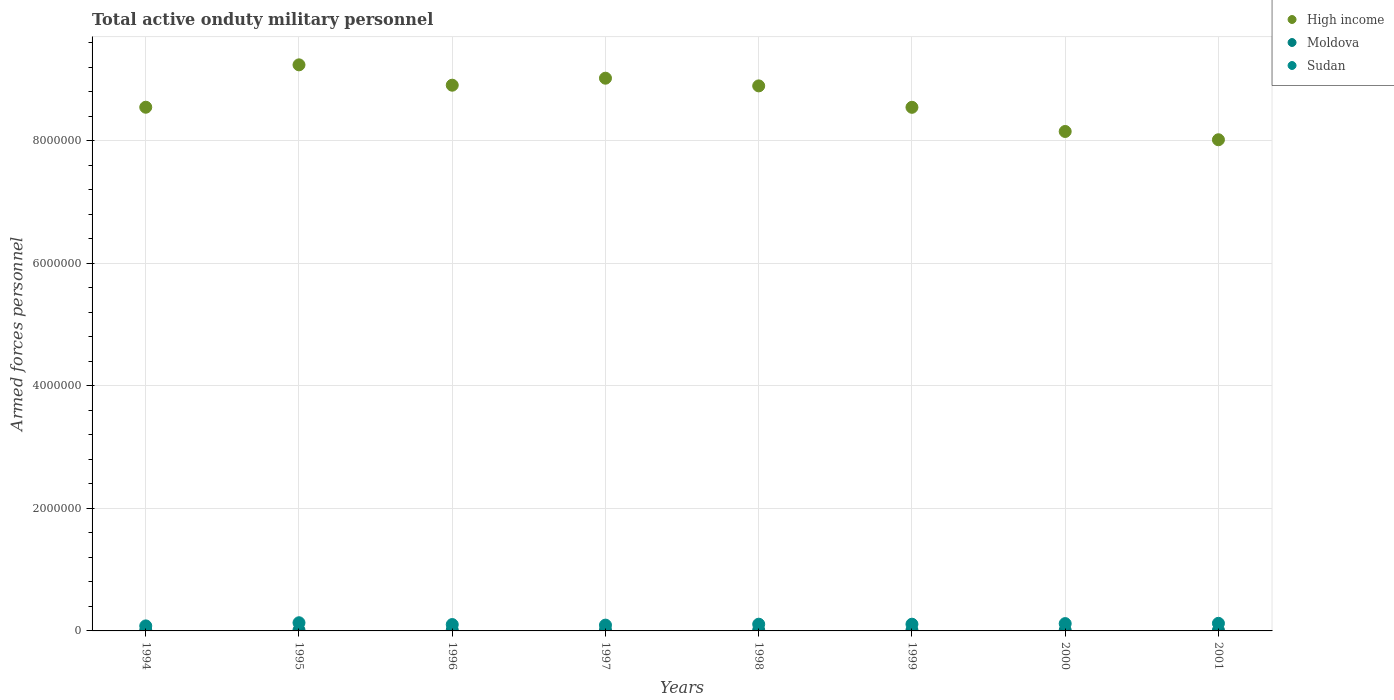How many different coloured dotlines are there?
Provide a succinct answer. 3. Is the number of dotlines equal to the number of legend labels?
Provide a succinct answer. Yes. What is the number of armed forces personnel in Sudan in 1999?
Offer a very short reply. 1.10e+05. Across all years, what is the maximum number of armed forces personnel in Sudan?
Make the answer very short. 1.34e+05. Across all years, what is the minimum number of armed forces personnel in Moldova?
Provide a succinct answer. 1.10e+04. In which year was the number of armed forces personnel in Sudan minimum?
Make the answer very short. 1994. What is the total number of armed forces personnel in High income in the graph?
Keep it short and to the point. 6.94e+07. What is the difference between the number of armed forces personnel in High income in 1998 and that in 2001?
Give a very brief answer. 8.79e+05. What is the difference between the number of armed forces personnel in Sudan in 2000 and the number of armed forces personnel in Moldova in 2001?
Your answer should be very brief. 1.08e+05. What is the average number of armed forces personnel in Moldova per year?
Your response must be concise. 1.36e+04. In the year 1994, what is the difference between the number of armed forces personnel in Moldova and number of armed forces personnel in High income?
Your response must be concise. -8.54e+06. What is the ratio of the number of armed forces personnel in Moldova in 1995 to that in 1996?
Provide a short and direct response. 1. Is the number of armed forces personnel in High income in 1997 less than that in 2001?
Give a very brief answer. No. What is the difference between the highest and the second highest number of armed forces personnel in High income?
Provide a succinct answer. 2.18e+05. What is the difference between the highest and the lowest number of armed forces personnel in Moldova?
Make the answer very short. 4300. In how many years, is the number of armed forces personnel in High income greater than the average number of armed forces personnel in High income taken over all years?
Give a very brief answer. 4. Is the sum of the number of armed forces personnel in High income in 1998 and 1999 greater than the maximum number of armed forces personnel in Sudan across all years?
Ensure brevity in your answer.  Yes. Does the number of armed forces personnel in Sudan monotonically increase over the years?
Give a very brief answer. No. Is the number of armed forces personnel in High income strictly greater than the number of armed forces personnel in Sudan over the years?
Your answer should be very brief. Yes. Does the graph contain any zero values?
Give a very brief answer. No. Does the graph contain grids?
Provide a short and direct response. Yes. What is the title of the graph?
Give a very brief answer. Total active onduty military personnel. What is the label or title of the Y-axis?
Provide a succinct answer. Armed forces personnel. What is the Armed forces personnel of High income in 1994?
Ensure brevity in your answer.  8.55e+06. What is the Armed forces personnel in Moldova in 1994?
Make the answer very short. 1.10e+04. What is the Armed forces personnel of Sudan in 1994?
Provide a short and direct response. 8.20e+04. What is the Armed forces personnel of High income in 1995?
Ensure brevity in your answer.  9.24e+06. What is the Armed forces personnel in Moldova in 1995?
Keep it short and to the point. 1.53e+04. What is the Armed forces personnel of Sudan in 1995?
Offer a terse response. 1.34e+05. What is the Armed forces personnel of High income in 1996?
Offer a very short reply. 8.91e+06. What is the Armed forces personnel of Moldova in 1996?
Your response must be concise. 1.53e+04. What is the Armed forces personnel of Sudan in 1996?
Your answer should be compact. 1.04e+05. What is the Armed forces personnel of High income in 1997?
Offer a very short reply. 9.03e+06. What is the Armed forces personnel of Moldova in 1997?
Ensure brevity in your answer.  1.44e+04. What is the Armed forces personnel of Sudan in 1997?
Your response must be concise. 9.47e+04. What is the Armed forces personnel in High income in 1998?
Provide a succinct answer. 8.90e+06. What is the Armed forces personnel of Moldova in 1998?
Offer a terse response. 1.44e+04. What is the Armed forces personnel of Sudan in 1998?
Your answer should be compact. 1.10e+05. What is the Armed forces personnel of High income in 1999?
Provide a succinct answer. 8.55e+06. What is the Armed forces personnel in Moldova in 1999?
Provide a short and direct response. 1.40e+04. What is the Armed forces personnel in Sudan in 1999?
Make the answer very short. 1.10e+05. What is the Armed forces personnel of High income in 2000?
Your response must be concise. 8.16e+06. What is the Armed forces personnel of Moldova in 2000?
Your response must be concise. 1.29e+04. What is the Armed forces personnel in Sudan in 2000?
Give a very brief answer. 1.20e+05. What is the Armed forces personnel in High income in 2001?
Offer a terse response. 8.02e+06. What is the Armed forces personnel in Moldova in 2001?
Offer a terse response. 1.16e+04. What is the Armed forces personnel of Sudan in 2001?
Make the answer very short. 1.24e+05. Across all years, what is the maximum Armed forces personnel in High income?
Give a very brief answer. 9.24e+06. Across all years, what is the maximum Armed forces personnel of Moldova?
Ensure brevity in your answer.  1.53e+04. Across all years, what is the maximum Armed forces personnel of Sudan?
Your answer should be compact. 1.34e+05. Across all years, what is the minimum Armed forces personnel in High income?
Offer a terse response. 8.02e+06. Across all years, what is the minimum Armed forces personnel in Moldova?
Keep it short and to the point. 1.10e+04. Across all years, what is the minimum Armed forces personnel of Sudan?
Provide a succinct answer. 8.20e+04. What is the total Armed forces personnel of High income in the graph?
Your response must be concise. 6.94e+07. What is the total Armed forces personnel in Moldova in the graph?
Your answer should be very brief. 1.09e+05. What is the total Armed forces personnel in Sudan in the graph?
Offer a very short reply. 8.77e+05. What is the difference between the Armed forces personnel of High income in 1994 and that in 1995?
Provide a succinct answer. -6.92e+05. What is the difference between the Armed forces personnel in Moldova in 1994 and that in 1995?
Provide a succinct answer. -4300. What is the difference between the Armed forces personnel in Sudan in 1994 and that in 1995?
Provide a short and direct response. -5.15e+04. What is the difference between the Armed forces personnel in High income in 1994 and that in 1996?
Make the answer very short. -3.60e+05. What is the difference between the Armed forces personnel in Moldova in 1994 and that in 1996?
Provide a short and direct response. -4300. What is the difference between the Armed forces personnel of Sudan in 1994 and that in 1996?
Ensure brevity in your answer.  -2.20e+04. What is the difference between the Armed forces personnel in High income in 1994 and that in 1997?
Provide a short and direct response. -4.74e+05. What is the difference between the Armed forces personnel in Moldova in 1994 and that in 1997?
Your answer should be very brief. -3430. What is the difference between the Armed forces personnel in Sudan in 1994 and that in 1997?
Make the answer very short. -1.27e+04. What is the difference between the Armed forces personnel in High income in 1994 and that in 1998?
Provide a succinct answer. -3.48e+05. What is the difference between the Armed forces personnel of Moldova in 1994 and that in 1998?
Offer a very short reply. -3450. What is the difference between the Armed forces personnel in Sudan in 1994 and that in 1998?
Your answer should be very brief. -2.77e+04. What is the difference between the Armed forces personnel in High income in 1994 and that in 1999?
Give a very brief answer. 1230. What is the difference between the Armed forces personnel of Moldova in 1994 and that in 1999?
Make the answer very short. -3050. What is the difference between the Armed forces personnel of Sudan in 1994 and that in 1999?
Give a very brief answer. -2.77e+04. What is the difference between the Armed forces personnel of High income in 1994 and that in 2000?
Make the answer very short. 3.96e+05. What is the difference between the Armed forces personnel in Moldova in 1994 and that in 2000?
Provide a short and direct response. -1900. What is the difference between the Armed forces personnel of Sudan in 1994 and that in 2000?
Provide a succinct answer. -3.75e+04. What is the difference between the Armed forces personnel of High income in 1994 and that in 2001?
Offer a very short reply. 5.31e+05. What is the difference between the Armed forces personnel of Moldova in 1994 and that in 2001?
Give a very brief answer. -600. What is the difference between the Armed forces personnel of Sudan in 1994 and that in 2001?
Give a very brief answer. -4.20e+04. What is the difference between the Armed forces personnel in High income in 1995 and that in 1996?
Make the answer very short. 3.32e+05. What is the difference between the Armed forces personnel of Sudan in 1995 and that in 1996?
Offer a very short reply. 2.95e+04. What is the difference between the Armed forces personnel in High income in 1995 and that in 1997?
Give a very brief answer. 2.18e+05. What is the difference between the Armed forces personnel of Moldova in 1995 and that in 1997?
Your answer should be compact. 870. What is the difference between the Armed forces personnel in Sudan in 1995 and that in 1997?
Keep it short and to the point. 3.88e+04. What is the difference between the Armed forces personnel in High income in 1995 and that in 1998?
Offer a terse response. 3.44e+05. What is the difference between the Armed forces personnel of Moldova in 1995 and that in 1998?
Offer a very short reply. 850. What is the difference between the Armed forces personnel of Sudan in 1995 and that in 1998?
Provide a succinct answer. 2.38e+04. What is the difference between the Armed forces personnel of High income in 1995 and that in 1999?
Offer a terse response. 6.93e+05. What is the difference between the Armed forces personnel of Moldova in 1995 and that in 1999?
Make the answer very short. 1250. What is the difference between the Armed forces personnel of Sudan in 1995 and that in 1999?
Keep it short and to the point. 2.38e+04. What is the difference between the Armed forces personnel of High income in 1995 and that in 2000?
Ensure brevity in your answer.  1.09e+06. What is the difference between the Armed forces personnel of Moldova in 1995 and that in 2000?
Offer a terse response. 2400. What is the difference between the Armed forces personnel in Sudan in 1995 and that in 2000?
Offer a terse response. 1.40e+04. What is the difference between the Armed forces personnel in High income in 1995 and that in 2001?
Give a very brief answer. 1.22e+06. What is the difference between the Armed forces personnel of Moldova in 1995 and that in 2001?
Your answer should be compact. 3700. What is the difference between the Armed forces personnel of Sudan in 1995 and that in 2001?
Ensure brevity in your answer.  9500. What is the difference between the Armed forces personnel of High income in 1996 and that in 1997?
Provide a succinct answer. -1.14e+05. What is the difference between the Armed forces personnel of Moldova in 1996 and that in 1997?
Give a very brief answer. 870. What is the difference between the Armed forces personnel of Sudan in 1996 and that in 1997?
Provide a succinct answer. 9300. What is the difference between the Armed forces personnel of High income in 1996 and that in 1998?
Your answer should be compact. 1.13e+04. What is the difference between the Armed forces personnel of Moldova in 1996 and that in 1998?
Ensure brevity in your answer.  850. What is the difference between the Armed forces personnel of Sudan in 1996 and that in 1998?
Keep it short and to the point. -5700. What is the difference between the Armed forces personnel in High income in 1996 and that in 1999?
Offer a very short reply. 3.61e+05. What is the difference between the Armed forces personnel of Moldova in 1996 and that in 1999?
Your answer should be very brief. 1250. What is the difference between the Armed forces personnel in Sudan in 1996 and that in 1999?
Give a very brief answer. -5700. What is the difference between the Armed forces personnel of High income in 1996 and that in 2000?
Your answer should be very brief. 7.56e+05. What is the difference between the Armed forces personnel in Moldova in 1996 and that in 2000?
Offer a very short reply. 2400. What is the difference between the Armed forces personnel in Sudan in 1996 and that in 2000?
Your answer should be very brief. -1.55e+04. What is the difference between the Armed forces personnel of High income in 1996 and that in 2001?
Your response must be concise. 8.91e+05. What is the difference between the Armed forces personnel in Moldova in 1996 and that in 2001?
Ensure brevity in your answer.  3700. What is the difference between the Armed forces personnel of High income in 1997 and that in 1998?
Ensure brevity in your answer.  1.26e+05. What is the difference between the Armed forces personnel in Sudan in 1997 and that in 1998?
Offer a very short reply. -1.50e+04. What is the difference between the Armed forces personnel in High income in 1997 and that in 1999?
Give a very brief answer. 4.75e+05. What is the difference between the Armed forces personnel in Moldova in 1997 and that in 1999?
Ensure brevity in your answer.  380. What is the difference between the Armed forces personnel in Sudan in 1997 and that in 1999?
Keep it short and to the point. -1.50e+04. What is the difference between the Armed forces personnel of High income in 1997 and that in 2000?
Ensure brevity in your answer.  8.70e+05. What is the difference between the Armed forces personnel in Moldova in 1997 and that in 2000?
Give a very brief answer. 1530. What is the difference between the Armed forces personnel in Sudan in 1997 and that in 2000?
Your answer should be compact. -2.48e+04. What is the difference between the Armed forces personnel of High income in 1997 and that in 2001?
Your response must be concise. 1.01e+06. What is the difference between the Armed forces personnel of Moldova in 1997 and that in 2001?
Ensure brevity in your answer.  2830. What is the difference between the Armed forces personnel of Sudan in 1997 and that in 2001?
Keep it short and to the point. -2.93e+04. What is the difference between the Armed forces personnel of High income in 1998 and that in 1999?
Offer a terse response. 3.50e+05. What is the difference between the Armed forces personnel in Moldova in 1998 and that in 1999?
Offer a terse response. 400. What is the difference between the Armed forces personnel of High income in 1998 and that in 2000?
Give a very brief answer. 7.44e+05. What is the difference between the Armed forces personnel of Moldova in 1998 and that in 2000?
Offer a terse response. 1550. What is the difference between the Armed forces personnel in Sudan in 1998 and that in 2000?
Give a very brief answer. -9800. What is the difference between the Armed forces personnel in High income in 1998 and that in 2001?
Ensure brevity in your answer.  8.79e+05. What is the difference between the Armed forces personnel in Moldova in 1998 and that in 2001?
Your answer should be very brief. 2850. What is the difference between the Armed forces personnel in Sudan in 1998 and that in 2001?
Your answer should be very brief. -1.43e+04. What is the difference between the Armed forces personnel in High income in 1999 and that in 2000?
Your answer should be compact. 3.95e+05. What is the difference between the Armed forces personnel in Moldova in 1999 and that in 2000?
Offer a terse response. 1150. What is the difference between the Armed forces personnel of Sudan in 1999 and that in 2000?
Offer a terse response. -9800. What is the difference between the Armed forces personnel in High income in 1999 and that in 2001?
Your answer should be compact. 5.30e+05. What is the difference between the Armed forces personnel of Moldova in 1999 and that in 2001?
Offer a very short reply. 2450. What is the difference between the Armed forces personnel of Sudan in 1999 and that in 2001?
Keep it short and to the point. -1.43e+04. What is the difference between the Armed forces personnel of High income in 2000 and that in 2001?
Offer a terse response. 1.35e+05. What is the difference between the Armed forces personnel in Moldova in 2000 and that in 2001?
Make the answer very short. 1300. What is the difference between the Armed forces personnel in Sudan in 2000 and that in 2001?
Offer a very short reply. -4500. What is the difference between the Armed forces personnel of High income in 1994 and the Armed forces personnel of Moldova in 1995?
Keep it short and to the point. 8.54e+06. What is the difference between the Armed forces personnel in High income in 1994 and the Armed forces personnel in Sudan in 1995?
Offer a very short reply. 8.42e+06. What is the difference between the Armed forces personnel of Moldova in 1994 and the Armed forces personnel of Sudan in 1995?
Your response must be concise. -1.22e+05. What is the difference between the Armed forces personnel in High income in 1994 and the Armed forces personnel in Moldova in 1996?
Make the answer very short. 8.54e+06. What is the difference between the Armed forces personnel in High income in 1994 and the Armed forces personnel in Sudan in 1996?
Make the answer very short. 8.45e+06. What is the difference between the Armed forces personnel in Moldova in 1994 and the Armed forces personnel in Sudan in 1996?
Offer a very short reply. -9.30e+04. What is the difference between the Armed forces personnel of High income in 1994 and the Armed forces personnel of Moldova in 1997?
Your response must be concise. 8.54e+06. What is the difference between the Armed forces personnel in High income in 1994 and the Armed forces personnel in Sudan in 1997?
Ensure brevity in your answer.  8.46e+06. What is the difference between the Armed forces personnel in Moldova in 1994 and the Armed forces personnel in Sudan in 1997?
Give a very brief answer. -8.37e+04. What is the difference between the Armed forces personnel of High income in 1994 and the Armed forces personnel of Moldova in 1998?
Offer a terse response. 8.54e+06. What is the difference between the Armed forces personnel in High income in 1994 and the Armed forces personnel in Sudan in 1998?
Give a very brief answer. 8.44e+06. What is the difference between the Armed forces personnel in Moldova in 1994 and the Armed forces personnel in Sudan in 1998?
Make the answer very short. -9.87e+04. What is the difference between the Armed forces personnel in High income in 1994 and the Armed forces personnel in Moldova in 1999?
Provide a short and direct response. 8.54e+06. What is the difference between the Armed forces personnel in High income in 1994 and the Armed forces personnel in Sudan in 1999?
Give a very brief answer. 8.44e+06. What is the difference between the Armed forces personnel of Moldova in 1994 and the Armed forces personnel of Sudan in 1999?
Your response must be concise. -9.87e+04. What is the difference between the Armed forces personnel of High income in 1994 and the Armed forces personnel of Moldova in 2000?
Provide a short and direct response. 8.54e+06. What is the difference between the Armed forces personnel in High income in 1994 and the Armed forces personnel in Sudan in 2000?
Your answer should be compact. 8.43e+06. What is the difference between the Armed forces personnel of Moldova in 1994 and the Armed forces personnel of Sudan in 2000?
Your answer should be very brief. -1.08e+05. What is the difference between the Armed forces personnel in High income in 1994 and the Armed forces personnel in Moldova in 2001?
Provide a short and direct response. 8.54e+06. What is the difference between the Armed forces personnel of High income in 1994 and the Armed forces personnel of Sudan in 2001?
Your response must be concise. 8.43e+06. What is the difference between the Armed forces personnel in Moldova in 1994 and the Armed forces personnel in Sudan in 2001?
Your answer should be very brief. -1.13e+05. What is the difference between the Armed forces personnel of High income in 1995 and the Armed forces personnel of Moldova in 1996?
Offer a terse response. 9.23e+06. What is the difference between the Armed forces personnel of High income in 1995 and the Armed forces personnel of Sudan in 1996?
Offer a very short reply. 9.14e+06. What is the difference between the Armed forces personnel in Moldova in 1995 and the Armed forces personnel in Sudan in 1996?
Keep it short and to the point. -8.87e+04. What is the difference between the Armed forces personnel of High income in 1995 and the Armed forces personnel of Moldova in 1997?
Keep it short and to the point. 9.23e+06. What is the difference between the Armed forces personnel of High income in 1995 and the Armed forces personnel of Sudan in 1997?
Your response must be concise. 9.15e+06. What is the difference between the Armed forces personnel of Moldova in 1995 and the Armed forces personnel of Sudan in 1997?
Offer a very short reply. -7.94e+04. What is the difference between the Armed forces personnel of High income in 1995 and the Armed forces personnel of Moldova in 1998?
Your response must be concise. 9.23e+06. What is the difference between the Armed forces personnel of High income in 1995 and the Armed forces personnel of Sudan in 1998?
Keep it short and to the point. 9.13e+06. What is the difference between the Armed forces personnel of Moldova in 1995 and the Armed forces personnel of Sudan in 1998?
Your answer should be very brief. -9.44e+04. What is the difference between the Armed forces personnel in High income in 1995 and the Armed forces personnel in Moldova in 1999?
Offer a terse response. 9.23e+06. What is the difference between the Armed forces personnel of High income in 1995 and the Armed forces personnel of Sudan in 1999?
Provide a succinct answer. 9.13e+06. What is the difference between the Armed forces personnel in Moldova in 1995 and the Armed forces personnel in Sudan in 1999?
Provide a short and direct response. -9.44e+04. What is the difference between the Armed forces personnel of High income in 1995 and the Armed forces personnel of Moldova in 2000?
Provide a succinct answer. 9.23e+06. What is the difference between the Armed forces personnel in High income in 1995 and the Armed forces personnel in Sudan in 2000?
Your answer should be very brief. 9.12e+06. What is the difference between the Armed forces personnel in Moldova in 1995 and the Armed forces personnel in Sudan in 2000?
Offer a terse response. -1.04e+05. What is the difference between the Armed forces personnel in High income in 1995 and the Armed forces personnel in Moldova in 2001?
Offer a very short reply. 9.23e+06. What is the difference between the Armed forces personnel of High income in 1995 and the Armed forces personnel of Sudan in 2001?
Your answer should be compact. 9.12e+06. What is the difference between the Armed forces personnel of Moldova in 1995 and the Armed forces personnel of Sudan in 2001?
Give a very brief answer. -1.09e+05. What is the difference between the Armed forces personnel of High income in 1996 and the Armed forces personnel of Moldova in 1997?
Give a very brief answer. 8.90e+06. What is the difference between the Armed forces personnel of High income in 1996 and the Armed forces personnel of Sudan in 1997?
Give a very brief answer. 8.82e+06. What is the difference between the Armed forces personnel in Moldova in 1996 and the Armed forces personnel in Sudan in 1997?
Give a very brief answer. -7.94e+04. What is the difference between the Armed forces personnel in High income in 1996 and the Armed forces personnel in Moldova in 1998?
Keep it short and to the point. 8.90e+06. What is the difference between the Armed forces personnel of High income in 1996 and the Armed forces personnel of Sudan in 1998?
Your response must be concise. 8.80e+06. What is the difference between the Armed forces personnel of Moldova in 1996 and the Armed forces personnel of Sudan in 1998?
Keep it short and to the point. -9.44e+04. What is the difference between the Armed forces personnel of High income in 1996 and the Armed forces personnel of Moldova in 1999?
Provide a short and direct response. 8.90e+06. What is the difference between the Armed forces personnel in High income in 1996 and the Armed forces personnel in Sudan in 1999?
Your response must be concise. 8.80e+06. What is the difference between the Armed forces personnel in Moldova in 1996 and the Armed forces personnel in Sudan in 1999?
Provide a succinct answer. -9.44e+04. What is the difference between the Armed forces personnel in High income in 1996 and the Armed forces personnel in Moldova in 2000?
Your response must be concise. 8.90e+06. What is the difference between the Armed forces personnel of High income in 1996 and the Armed forces personnel of Sudan in 2000?
Your answer should be compact. 8.79e+06. What is the difference between the Armed forces personnel in Moldova in 1996 and the Armed forces personnel in Sudan in 2000?
Provide a short and direct response. -1.04e+05. What is the difference between the Armed forces personnel in High income in 1996 and the Armed forces personnel in Moldova in 2001?
Your answer should be compact. 8.90e+06. What is the difference between the Armed forces personnel in High income in 1996 and the Armed forces personnel in Sudan in 2001?
Provide a short and direct response. 8.79e+06. What is the difference between the Armed forces personnel of Moldova in 1996 and the Armed forces personnel of Sudan in 2001?
Offer a very short reply. -1.09e+05. What is the difference between the Armed forces personnel of High income in 1997 and the Armed forces personnel of Moldova in 1998?
Your answer should be compact. 9.01e+06. What is the difference between the Armed forces personnel of High income in 1997 and the Armed forces personnel of Sudan in 1998?
Your answer should be very brief. 8.92e+06. What is the difference between the Armed forces personnel of Moldova in 1997 and the Armed forces personnel of Sudan in 1998?
Keep it short and to the point. -9.53e+04. What is the difference between the Armed forces personnel in High income in 1997 and the Armed forces personnel in Moldova in 1999?
Offer a terse response. 9.01e+06. What is the difference between the Armed forces personnel in High income in 1997 and the Armed forces personnel in Sudan in 1999?
Provide a short and direct response. 8.92e+06. What is the difference between the Armed forces personnel of Moldova in 1997 and the Armed forces personnel of Sudan in 1999?
Provide a succinct answer. -9.53e+04. What is the difference between the Armed forces personnel of High income in 1997 and the Armed forces personnel of Moldova in 2000?
Give a very brief answer. 9.01e+06. What is the difference between the Armed forces personnel in High income in 1997 and the Armed forces personnel in Sudan in 2000?
Offer a terse response. 8.91e+06. What is the difference between the Armed forces personnel in Moldova in 1997 and the Armed forces personnel in Sudan in 2000?
Your answer should be compact. -1.05e+05. What is the difference between the Armed forces personnel of High income in 1997 and the Armed forces personnel of Moldova in 2001?
Provide a succinct answer. 9.01e+06. What is the difference between the Armed forces personnel of High income in 1997 and the Armed forces personnel of Sudan in 2001?
Ensure brevity in your answer.  8.90e+06. What is the difference between the Armed forces personnel in Moldova in 1997 and the Armed forces personnel in Sudan in 2001?
Make the answer very short. -1.10e+05. What is the difference between the Armed forces personnel of High income in 1998 and the Armed forces personnel of Moldova in 1999?
Your response must be concise. 8.89e+06. What is the difference between the Armed forces personnel in High income in 1998 and the Armed forces personnel in Sudan in 1999?
Make the answer very short. 8.79e+06. What is the difference between the Armed forces personnel of Moldova in 1998 and the Armed forces personnel of Sudan in 1999?
Ensure brevity in your answer.  -9.52e+04. What is the difference between the Armed forces personnel of High income in 1998 and the Armed forces personnel of Moldova in 2000?
Make the answer very short. 8.89e+06. What is the difference between the Armed forces personnel of High income in 1998 and the Armed forces personnel of Sudan in 2000?
Provide a succinct answer. 8.78e+06. What is the difference between the Armed forces personnel in Moldova in 1998 and the Armed forces personnel in Sudan in 2000?
Make the answer very short. -1.05e+05. What is the difference between the Armed forces personnel in High income in 1998 and the Armed forces personnel in Moldova in 2001?
Offer a very short reply. 8.89e+06. What is the difference between the Armed forces personnel in High income in 1998 and the Armed forces personnel in Sudan in 2001?
Offer a terse response. 8.78e+06. What is the difference between the Armed forces personnel of Moldova in 1998 and the Armed forces personnel of Sudan in 2001?
Keep it short and to the point. -1.10e+05. What is the difference between the Armed forces personnel of High income in 1999 and the Armed forces personnel of Moldova in 2000?
Offer a terse response. 8.54e+06. What is the difference between the Armed forces personnel in High income in 1999 and the Armed forces personnel in Sudan in 2000?
Provide a short and direct response. 8.43e+06. What is the difference between the Armed forces personnel in Moldova in 1999 and the Armed forces personnel in Sudan in 2000?
Give a very brief answer. -1.05e+05. What is the difference between the Armed forces personnel of High income in 1999 and the Armed forces personnel of Moldova in 2001?
Provide a succinct answer. 8.54e+06. What is the difference between the Armed forces personnel of High income in 1999 and the Armed forces personnel of Sudan in 2001?
Provide a succinct answer. 8.43e+06. What is the difference between the Armed forces personnel of Moldova in 1999 and the Armed forces personnel of Sudan in 2001?
Provide a short and direct response. -1.10e+05. What is the difference between the Armed forces personnel in High income in 2000 and the Armed forces personnel in Moldova in 2001?
Ensure brevity in your answer.  8.14e+06. What is the difference between the Armed forces personnel in High income in 2000 and the Armed forces personnel in Sudan in 2001?
Your answer should be very brief. 8.03e+06. What is the difference between the Armed forces personnel of Moldova in 2000 and the Armed forces personnel of Sudan in 2001?
Your response must be concise. -1.11e+05. What is the average Armed forces personnel of High income per year?
Provide a succinct answer. 8.67e+06. What is the average Armed forces personnel of Moldova per year?
Your answer should be very brief. 1.36e+04. What is the average Armed forces personnel of Sudan per year?
Ensure brevity in your answer.  1.10e+05. In the year 1994, what is the difference between the Armed forces personnel of High income and Armed forces personnel of Moldova?
Offer a terse response. 8.54e+06. In the year 1994, what is the difference between the Armed forces personnel in High income and Armed forces personnel in Sudan?
Your answer should be very brief. 8.47e+06. In the year 1994, what is the difference between the Armed forces personnel of Moldova and Armed forces personnel of Sudan?
Offer a very short reply. -7.10e+04. In the year 1995, what is the difference between the Armed forces personnel of High income and Armed forces personnel of Moldova?
Offer a very short reply. 9.23e+06. In the year 1995, what is the difference between the Armed forces personnel in High income and Armed forces personnel in Sudan?
Make the answer very short. 9.11e+06. In the year 1995, what is the difference between the Armed forces personnel in Moldova and Armed forces personnel in Sudan?
Your answer should be very brief. -1.18e+05. In the year 1996, what is the difference between the Armed forces personnel in High income and Armed forces personnel in Moldova?
Make the answer very short. 8.90e+06. In the year 1996, what is the difference between the Armed forces personnel in High income and Armed forces personnel in Sudan?
Offer a very short reply. 8.81e+06. In the year 1996, what is the difference between the Armed forces personnel of Moldova and Armed forces personnel of Sudan?
Your answer should be very brief. -8.87e+04. In the year 1997, what is the difference between the Armed forces personnel of High income and Armed forces personnel of Moldova?
Offer a terse response. 9.01e+06. In the year 1997, what is the difference between the Armed forces personnel in High income and Armed forces personnel in Sudan?
Give a very brief answer. 8.93e+06. In the year 1997, what is the difference between the Armed forces personnel of Moldova and Armed forces personnel of Sudan?
Keep it short and to the point. -8.03e+04. In the year 1998, what is the difference between the Armed forces personnel in High income and Armed forces personnel in Moldova?
Provide a short and direct response. 8.89e+06. In the year 1998, what is the difference between the Armed forces personnel of High income and Armed forces personnel of Sudan?
Ensure brevity in your answer.  8.79e+06. In the year 1998, what is the difference between the Armed forces personnel in Moldova and Armed forces personnel in Sudan?
Offer a very short reply. -9.52e+04. In the year 1999, what is the difference between the Armed forces personnel of High income and Armed forces personnel of Moldova?
Give a very brief answer. 8.54e+06. In the year 1999, what is the difference between the Armed forces personnel in High income and Armed forces personnel in Sudan?
Your response must be concise. 8.44e+06. In the year 1999, what is the difference between the Armed forces personnel in Moldova and Armed forces personnel in Sudan?
Keep it short and to the point. -9.56e+04. In the year 2000, what is the difference between the Armed forces personnel in High income and Armed forces personnel in Moldova?
Make the answer very short. 8.14e+06. In the year 2000, what is the difference between the Armed forces personnel of High income and Armed forces personnel of Sudan?
Ensure brevity in your answer.  8.04e+06. In the year 2000, what is the difference between the Armed forces personnel in Moldova and Armed forces personnel in Sudan?
Offer a very short reply. -1.07e+05. In the year 2001, what is the difference between the Armed forces personnel of High income and Armed forces personnel of Moldova?
Your answer should be compact. 8.01e+06. In the year 2001, what is the difference between the Armed forces personnel of High income and Armed forces personnel of Sudan?
Keep it short and to the point. 7.90e+06. In the year 2001, what is the difference between the Armed forces personnel in Moldova and Armed forces personnel in Sudan?
Make the answer very short. -1.12e+05. What is the ratio of the Armed forces personnel of High income in 1994 to that in 1995?
Ensure brevity in your answer.  0.93. What is the ratio of the Armed forces personnel in Moldova in 1994 to that in 1995?
Your answer should be compact. 0.72. What is the ratio of the Armed forces personnel in Sudan in 1994 to that in 1995?
Make the answer very short. 0.61. What is the ratio of the Armed forces personnel in High income in 1994 to that in 1996?
Offer a terse response. 0.96. What is the ratio of the Armed forces personnel of Moldova in 1994 to that in 1996?
Make the answer very short. 0.72. What is the ratio of the Armed forces personnel of Sudan in 1994 to that in 1996?
Make the answer very short. 0.79. What is the ratio of the Armed forces personnel in High income in 1994 to that in 1997?
Provide a succinct answer. 0.95. What is the ratio of the Armed forces personnel of Moldova in 1994 to that in 1997?
Ensure brevity in your answer.  0.76. What is the ratio of the Armed forces personnel in Sudan in 1994 to that in 1997?
Make the answer very short. 0.87. What is the ratio of the Armed forces personnel of High income in 1994 to that in 1998?
Your answer should be compact. 0.96. What is the ratio of the Armed forces personnel in Moldova in 1994 to that in 1998?
Your answer should be compact. 0.76. What is the ratio of the Armed forces personnel of Sudan in 1994 to that in 1998?
Keep it short and to the point. 0.75. What is the ratio of the Armed forces personnel of High income in 1994 to that in 1999?
Offer a terse response. 1. What is the ratio of the Armed forces personnel of Moldova in 1994 to that in 1999?
Your answer should be compact. 0.78. What is the ratio of the Armed forces personnel of Sudan in 1994 to that in 1999?
Ensure brevity in your answer.  0.75. What is the ratio of the Armed forces personnel in High income in 1994 to that in 2000?
Ensure brevity in your answer.  1.05. What is the ratio of the Armed forces personnel in Moldova in 1994 to that in 2000?
Your answer should be very brief. 0.85. What is the ratio of the Armed forces personnel of Sudan in 1994 to that in 2000?
Offer a terse response. 0.69. What is the ratio of the Armed forces personnel in High income in 1994 to that in 2001?
Ensure brevity in your answer.  1.07. What is the ratio of the Armed forces personnel in Moldova in 1994 to that in 2001?
Keep it short and to the point. 0.95. What is the ratio of the Armed forces personnel of Sudan in 1994 to that in 2001?
Your response must be concise. 0.66. What is the ratio of the Armed forces personnel in High income in 1995 to that in 1996?
Give a very brief answer. 1.04. What is the ratio of the Armed forces personnel of Moldova in 1995 to that in 1996?
Keep it short and to the point. 1. What is the ratio of the Armed forces personnel of Sudan in 1995 to that in 1996?
Offer a very short reply. 1.28. What is the ratio of the Armed forces personnel of High income in 1995 to that in 1997?
Make the answer very short. 1.02. What is the ratio of the Armed forces personnel of Moldova in 1995 to that in 1997?
Offer a terse response. 1.06. What is the ratio of the Armed forces personnel in Sudan in 1995 to that in 1997?
Offer a very short reply. 1.41. What is the ratio of the Armed forces personnel of High income in 1995 to that in 1998?
Offer a terse response. 1.04. What is the ratio of the Armed forces personnel in Moldova in 1995 to that in 1998?
Your answer should be compact. 1.06. What is the ratio of the Armed forces personnel in Sudan in 1995 to that in 1998?
Offer a very short reply. 1.22. What is the ratio of the Armed forces personnel in High income in 1995 to that in 1999?
Your answer should be very brief. 1.08. What is the ratio of the Armed forces personnel of Moldova in 1995 to that in 1999?
Ensure brevity in your answer.  1.09. What is the ratio of the Armed forces personnel in Sudan in 1995 to that in 1999?
Your response must be concise. 1.22. What is the ratio of the Armed forces personnel of High income in 1995 to that in 2000?
Your answer should be very brief. 1.13. What is the ratio of the Armed forces personnel in Moldova in 1995 to that in 2000?
Your answer should be very brief. 1.19. What is the ratio of the Armed forces personnel in Sudan in 1995 to that in 2000?
Make the answer very short. 1.12. What is the ratio of the Armed forces personnel in High income in 1995 to that in 2001?
Give a very brief answer. 1.15. What is the ratio of the Armed forces personnel of Moldova in 1995 to that in 2001?
Provide a succinct answer. 1.32. What is the ratio of the Armed forces personnel of Sudan in 1995 to that in 2001?
Keep it short and to the point. 1.08. What is the ratio of the Armed forces personnel of High income in 1996 to that in 1997?
Your answer should be very brief. 0.99. What is the ratio of the Armed forces personnel of Moldova in 1996 to that in 1997?
Provide a succinct answer. 1.06. What is the ratio of the Armed forces personnel of Sudan in 1996 to that in 1997?
Make the answer very short. 1.1. What is the ratio of the Armed forces personnel of High income in 1996 to that in 1998?
Make the answer very short. 1. What is the ratio of the Armed forces personnel of Moldova in 1996 to that in 1998?
Your answer should be very brief. 1.06. What is the ratio of the Armed forces personnel of Sudan in 1996 to that in 1998?
Your answer should be very brief. 0.95. What is the ratio of the Armed forces personnel of High income in 1996 to that in 1999?
Your response must be concise. 1.04. What is the ratio of the Armed forces personnel of Moldova in 1996 to that in 1999?
Offer a terse response. 1.09. What is the ratio of the Armed forces personnel of Sudan in 1996 to that in 1999?
Keep it short and to the point. 0.95. What is the ratio of the Armed forces personnel in High income in 1996 to that in 2000?
Keep it short and to the point. 1.09. What is the ratio of the Armed forces personnel in Moldova in 1996 to that in 2000?
Your answer should be compact. 1.19. What is the ratio of the Armed forces personnel in Sudan in 1996 to that in 2000?
Keep it short and to the point. 0.87. What is the ratio of the Armed forces personnel in High income in 1996 to that in 2001?
Ensure brevity in your answer.  1.11. What is the ratio of the Armed forces personnel of Moldova in 1996 to that in 2001?
Give a very brief answer. 1.32. What is the ratio of the Armed forces personnel of Sudan in 1996 to that in 2001?
Provide a succinct answer. 0.84. What is the ratio of the Armed forces personnel of High income in 1997 to that in 1998?
Provide a succinct answer. 1.01. What is the ratio of the Armed forces personnel in Moldova in 1997 to that in 1998?
Your response must be concise. 1. What is the ratio of the Armed forces personnel of Sudan in 1997 to that in 1998?
Make the answer very short. 0.86. What is the ratio of the Armed forces personnel in High income in 1997 to that in 1999?
Give a very brief answer. 1.06. What is the ratio of the Armed forces personnel of Moldova in 1997 to that in 1999?
Your answer should be very brief. 1.03. What is the ratio of the Armed forces personnel in Sudan in 1997 to that in 1999?
Keep it short and to the point. 0.86. What is the ratio of the Armed forces personnel in High income in 1997 to that in 2000?
Offer a terse response. 1.11. What is the ratio of the Armed forces personnel of Moldova in 1997 to that in 2000?
Provide a short and direct response. 1.12. What is the ratio of the Armed forces personnel in Sudan in 1997 to that in 2000?
Provide a succinct answer. 0.79. What is the ratio of the Armed forces personnel in High income in 1997 to that in 2001?
Your answer should be very brief. 1.13. What is the ratio of the Armed forces personnel of Moldova in 1997 to that in 2001?
Offer a terse response. 1.24. What is the ratio of the Armed forces personnel of Sudan in 1997 to that in 2001?
Provide a short and direct response. 0.76. What is the ratio of the Armed forces personnel in High income in 1998 to that in 1999?
Your answer should be compact. 1.04. What is the ratio of the Armed forces personnel in Moldova in 1998 to that in 1999?
Ensure brevity in your answer.  1.03. What is the ratio of the Armed forces personnel in Sudan in 1998 to that in 1999?
Ensure brevity in your answer.  1. What is the ratio of the Armed forces personnel in High income in 1998 to that in 2000?
Provide a succinct answer. 1.09. What is the ratio of the Armed forces personnel of Moldova in 1998 to that in 2000?
Your answer should be compact. 1.12. What is the ratio of the Armed forces personnel in Sudan in 1998 to that in 2000?
Make the answer very short. 0.92. What is the ratio of the Armed forces personnel in High income in 1998 to that in 2001?
Offer a terse response. 1.11. What is the ratio of the Armed forces personnel of Moldova in 1998 to that in 2001?
Keep it short and to the point. 1.25. What is the ratio of the Armed forces personnel in Sudan in 1998 to that in 2001?
Give a very brief answer. 0.88. What is the ratio of the Armed forces personnel in High income in 1999 to that in 2000?
Give a very brief answer. 1.05. What is the ratio of the Armed forces personnel in Moldova in 1999 to that in 2000?
Provide a succinct answer. 1.09. What is the ratio of the Armed forces personnel of Sudan in 1999 to that in 2000?
Give a very brief answer. 0.92. What is the ratio of the Armed forces personnel of High income in 1999 to that in 2001?
Ensure brevity in your answer.  1.07. What is the ratio of the Armed forces personnel of Moldova in 1999 to that in 2001?
Keep it short and to the point. 1.21. What is the ratio of the Armed forces personnel in Sudan in 1999 to that in 2001?
Offer a very short reply. 0.88. What is the ratio of the Armed forces personnel in High income in 2000 to that in 2001?
Your response must be concise. 1.02. What is the ratio of the Armed forces personnel of Moldova in 2000 to that in 2001?
Give a very brief answer. 1.11. What is the ratio of the Armed forces personnel in Sudan in 2000 to that in 2001?
Make the answer very short. 0.96. What is the difference between the highest and the second highest Armed forces personnel in High income?
Provide a succinct answer. 2.18e+05. What is the difference between the highest and the second highest Armed forces personnel in Sudan?
Give a very brief answer. 9500. What is the difference between the highest and the lowest Armed forces personnel in High income?
Make the answer very short. 1.22e+06. What is the difference between the highest and the lowest Armed forces personnel of Moldova?
Provide a short and direct response. 4300. What is the difference between the highest and the lowest Armed forces personnel in Sudan?
Offer a very short reply. 5.15e+04. 